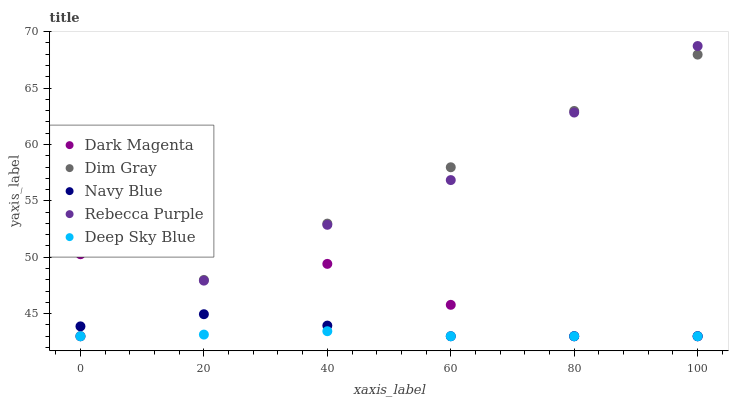Does Deep Sky Blue have the minimum area under the curve?
Answer yes or no. Yes. Does Dim Gray have the maximum area under the curve?
Answer yes or no. Yes. Does Dark Magenta have the minimum area under the curve?
Answer yes or no. No. Does Dark Magenta have the maximum area under the curve?
Answer yes or no. No. Is Dim Gray the smoothest?
Answer yes or no. Yes. Is Dark Magenta the roughest?
Answer yes or no. Yes. Is Dark Magenta the smoothest?
Answer yes or no. No. Is Dim Gray the roughest?
Answer yes or no. No. Does Navy Blue have the lowest value?
Answer yes or no. Yes. Does Rebecca Purple have the highest value?
Answer yes or no. Yes. Does Dim Gray have the highest value?
Answer yes or no. No. Does Deep Sky Blue intersect Dark Magenta?
Answer yes or no. Yes. Is Deep Sky Blue less than Dark Magenta?
Answer yes or no. No. Is Deep Sky Blue greater than Dark Magenta?
Answer yes or no. No. 